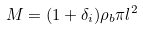<formula> <loc_0><loc_0><loc_500><loc_500>M = ( 1 + \delta _ { i } ) \rho _ { b } \pi l ^ { 2 }</formula> 